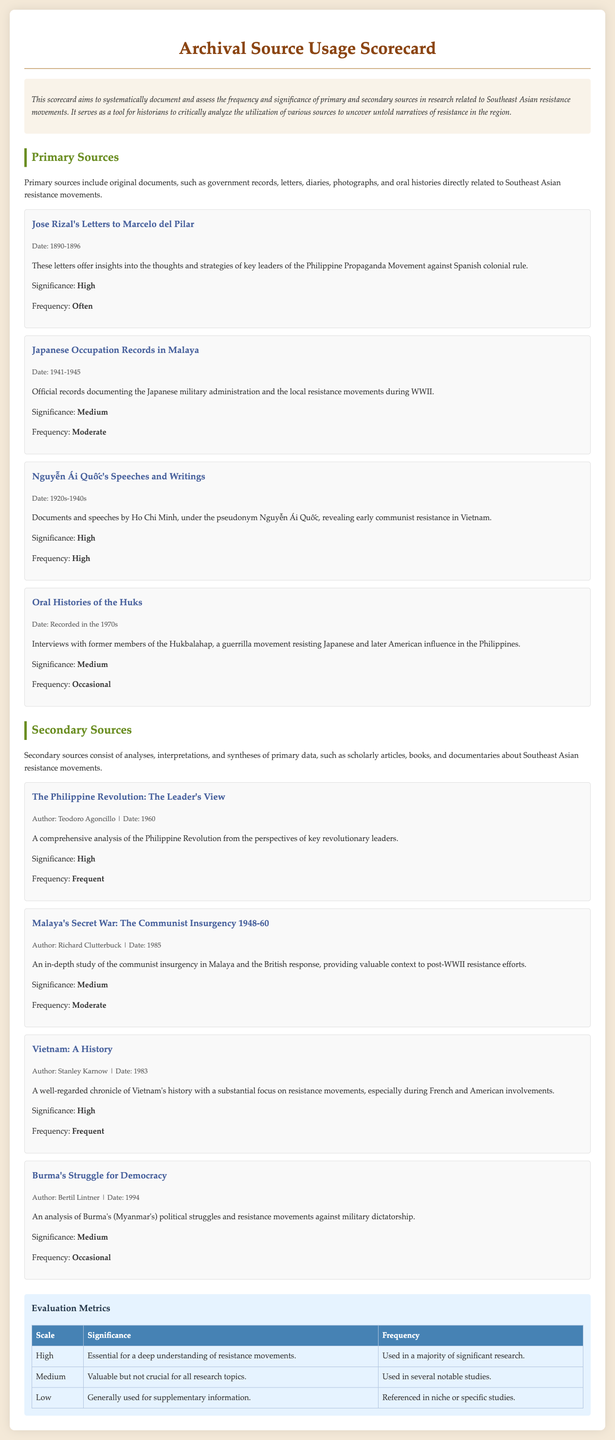What is the title of the scorecard? The title of the scorecard is presented prominently at the top of the document.
Answer: Archival Source Usage Scorecard Who authored "Malaya's Secret War: The Communist Insurgency 1948-60"? The author is specified under the title of the secondary source in the document.
Answer: Richard Clutterbuck What is the frequency of the primary source "Oral Histories of the Huks"? The frequency of each source is included as a descriptor within the source's information.
Answer: Occasional Which primary source has a significance level marked as "High"? Several primary sources are listed with their significance levels, which can be evaluated directly from the document.
Answer: Jose Rizal's Letters to Marcelo del Pilar How many primary sources are listed in the scorecard? The total number can be counted from the primary sources section of the document.
Answer: Four What is the date range for Nguyễn Ái Quốc's Speeches and Writings? The date range is provided as part of the metadata of the source.
Answer: 1920s-1940s What significance level does the secondary source "Vietnam: A History" have? The significance level is mentioned explicitly in the description of each secondary source.
Answer: High How is the frequency of the secondary source "Burma's Struggle for Democracy" described? Each secondary source contains a description of its usage frequency.
Answer: Occasional 